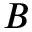Convert formula to latex. <formula><loc_0><loc_0><loc_500><loc_500>{ B }</formula> 